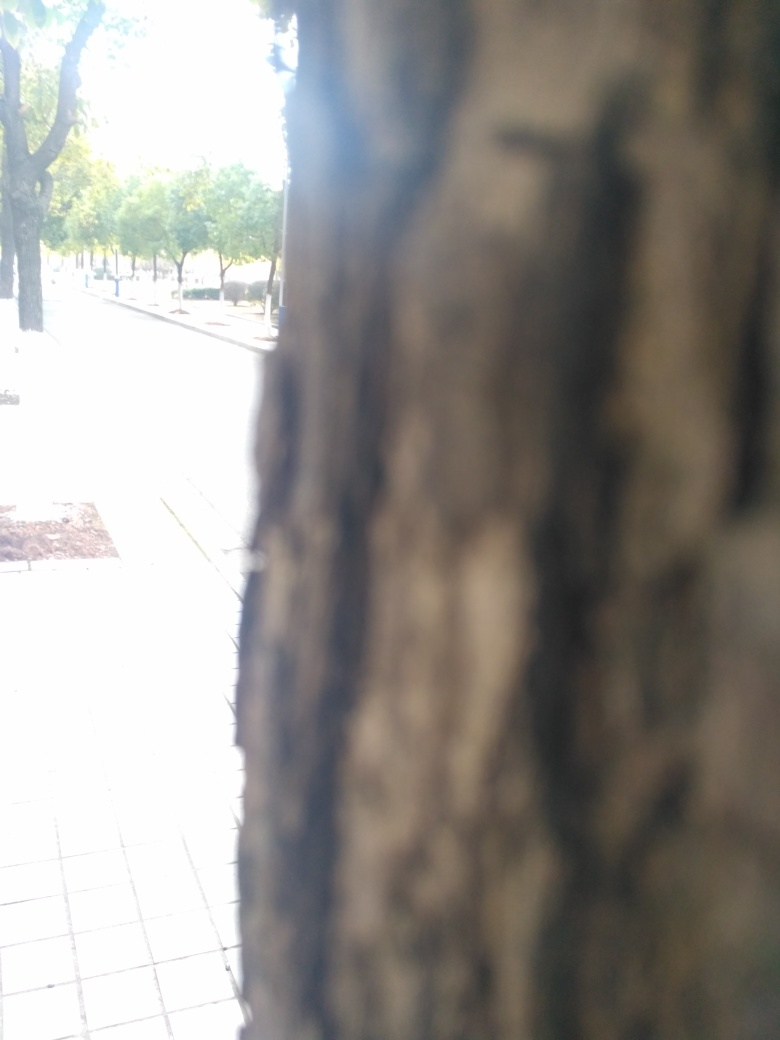What can be seen on both sides of the road?
A. cars
B. buildings
C. trees
Answer with the option's letter from the given choices directly. C. Trees can be observed lining both sides of the road, providing a scenic and verdant landscape, which contributes to a tranquil and refreshing atmosphere for pedestrians and probably enhancing the air quality in the area. 